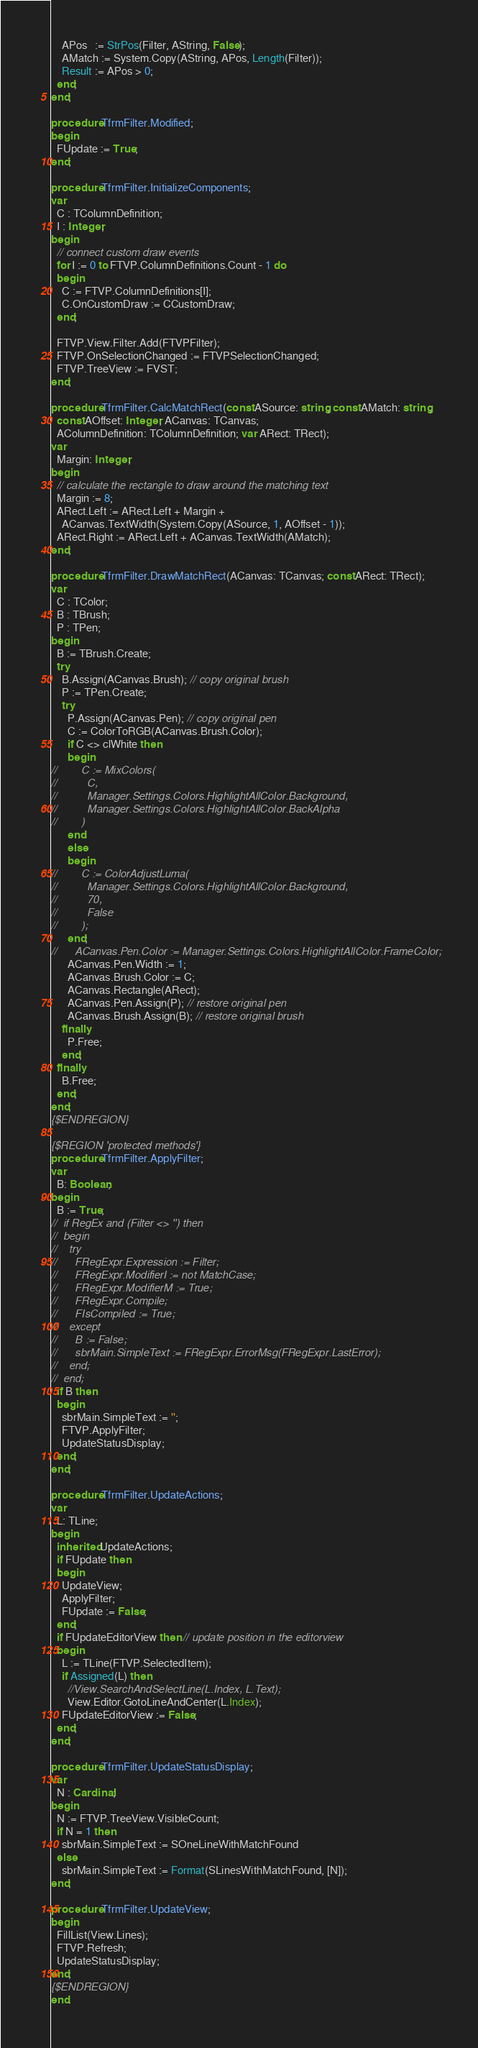Convert code to text. <code><loc_0><loc_0><loc_500><loc_500><_Pascal_>    APos   := StrPos(Filter, AString, False);
    AMatch := System.Copy(AString, APos, Length(Filter));
    Result := APos > 0;
  end;
end;

procedure TfrmFilter.Modified;
begin
  FUpdate := True;
end;

procedure TfrmFilter.InitializeComponents;
var
  C : TColumnDefinition;
  I : Integer;
begin
  // connect custom draw events
  for I := 0 to FTVP.ColumnDefinitions.Count - 1 do
  begin
    C := FTVP.ColumnDefinitions[I];
    C.OnCustomDraw := CCustomDraw;
  end;

  FTVP.View.Filter.Add(FTVPFilter);
  FTVP.OnSelectionChanged := FTVPSelectionChanged;
  FTVP.TreeView := FVST;
end;

procedure TfrmFilter.CalcMatchRect(const ASource: string; const AMatch: string;
  const AOffset: Integer; ACanvas: TCanvas;
  AColumnDefinition: TColumnDefinition; var ARect: TRect);
var
  Margin: Integer;
begin
  // calculate the rectangle to draw around the matching text
  Margin := 8;
  ARect.Left := ARect.Left + Margin +
    ACanvas.TextWidth(System.Copy(ASource, 1, AOffset - 1));
  ARect.Right := ARect.Left + ACanvas.TextWidth(AMatch);
end;

procedure TfrmFilter.DrawMatchRect(ACanvas: TCanvas; const ARect: TRect);
var
  C : TColor;
  B : TBrush;
  P : TPen;
begin
  B := TBrush.Create;
  try
    B.Assign(ACanvas.Brush); // copy original brush
    P := TPen.Create;
    try
      P.Assign(ACanvas.Pen); // copy original pen
      C := ColorToRGB(ACanvas.Brush.Color);
      if C <> clWhite then
      begin
//        C := MixColors(
//          C,
//          Manager.Settings.Colors.HighlightAllColor.Background,
//          Manager.Settings.Colors.HighlightAllColor.BackAlpha
//        )
      end
      else
      begin
//        C := ColorAdjustLuma(
//          Manager.Settings.Colors.HighlightAllColor.Background,
//          70,
//          False
//        );
      end;
//      ACanvas.Pen.Color := Manager.Settings.Colors.HighlightAllColor.FrameColor;
      ACanvas.Pen.Width := 1;
      ACanvas.Brush.Color := C;
      ACanvas.Rectangle(ARect);
      ACanvas.Pen.Assign(P); // restore original pen
      ACanvas.Brush.Assign(B); // restore original brush
    finally
      P.Free;
    end;
  finally
    B.Free;
  end;
end;
{$ENDREGION}

{$REGION 'protected methods'}
procedure TfrmFilter.ApplyFilter;
var
  B: Boolean;
begin
  B := True;
//  if RegEx and (Filter <> '') then
//  begin
//    try
//      FRegExpr.Expression := Filter;
//      FRegExpr.ModifierI := not MatchCase;
//      FRegExpr.ModifierM := True;
//      FRegExpr.Compile;
//      FIsCompiled := True;
//    except
//      B := False;
//      sbrMain.SimpleText := FRegExpr.ErrorMsg(FRegExpr.LastError);
//    end;
//  end;
  if B then
  begin
    sbrMain.SimpleText := '';
    FTVP.ApplyFilter;
    UpdateStatusDisplay;
  end;
end;

procedure TfrmFilter.UpdateActions;
var
  L: TLine;
begin
  inherited UpdateActions;
  if FUpdate then
  begin
    UpdateView;
    ApplyFilter;
    FUpdate := False;
  end;
  if FUpdateEditorView then // update position in the editorview
  begin
    L := TLine(FTVP.SelectedItem);
    if Assigned(L) then
      //View.SearchAndSelectLine(L.Index, L.Text);
      View.Editor.GotoLineAndCenter(L.Index);
    FUpdateEditorView := False;
  end;
end;

procedure TfrmFilter.UpdateStatusDisplay;
var
  N : Cardinal;
begin
  N := FTVP.TreeView.VisibleCount;
  if N = 1 then
    sbrMain.SimpleText := SOneLineWithMatchFound
  else
    sbrMain.SimpleText := Format(SLinesWithMatchFound, [N]);
end;

procedure TfrmFilter.UpdateView;
begin
  FillList(View.Lines);
  FTVP.Refresh;
  UpdateStatusDisplay;
end;
{$ENDREGION}
end.
</code> 